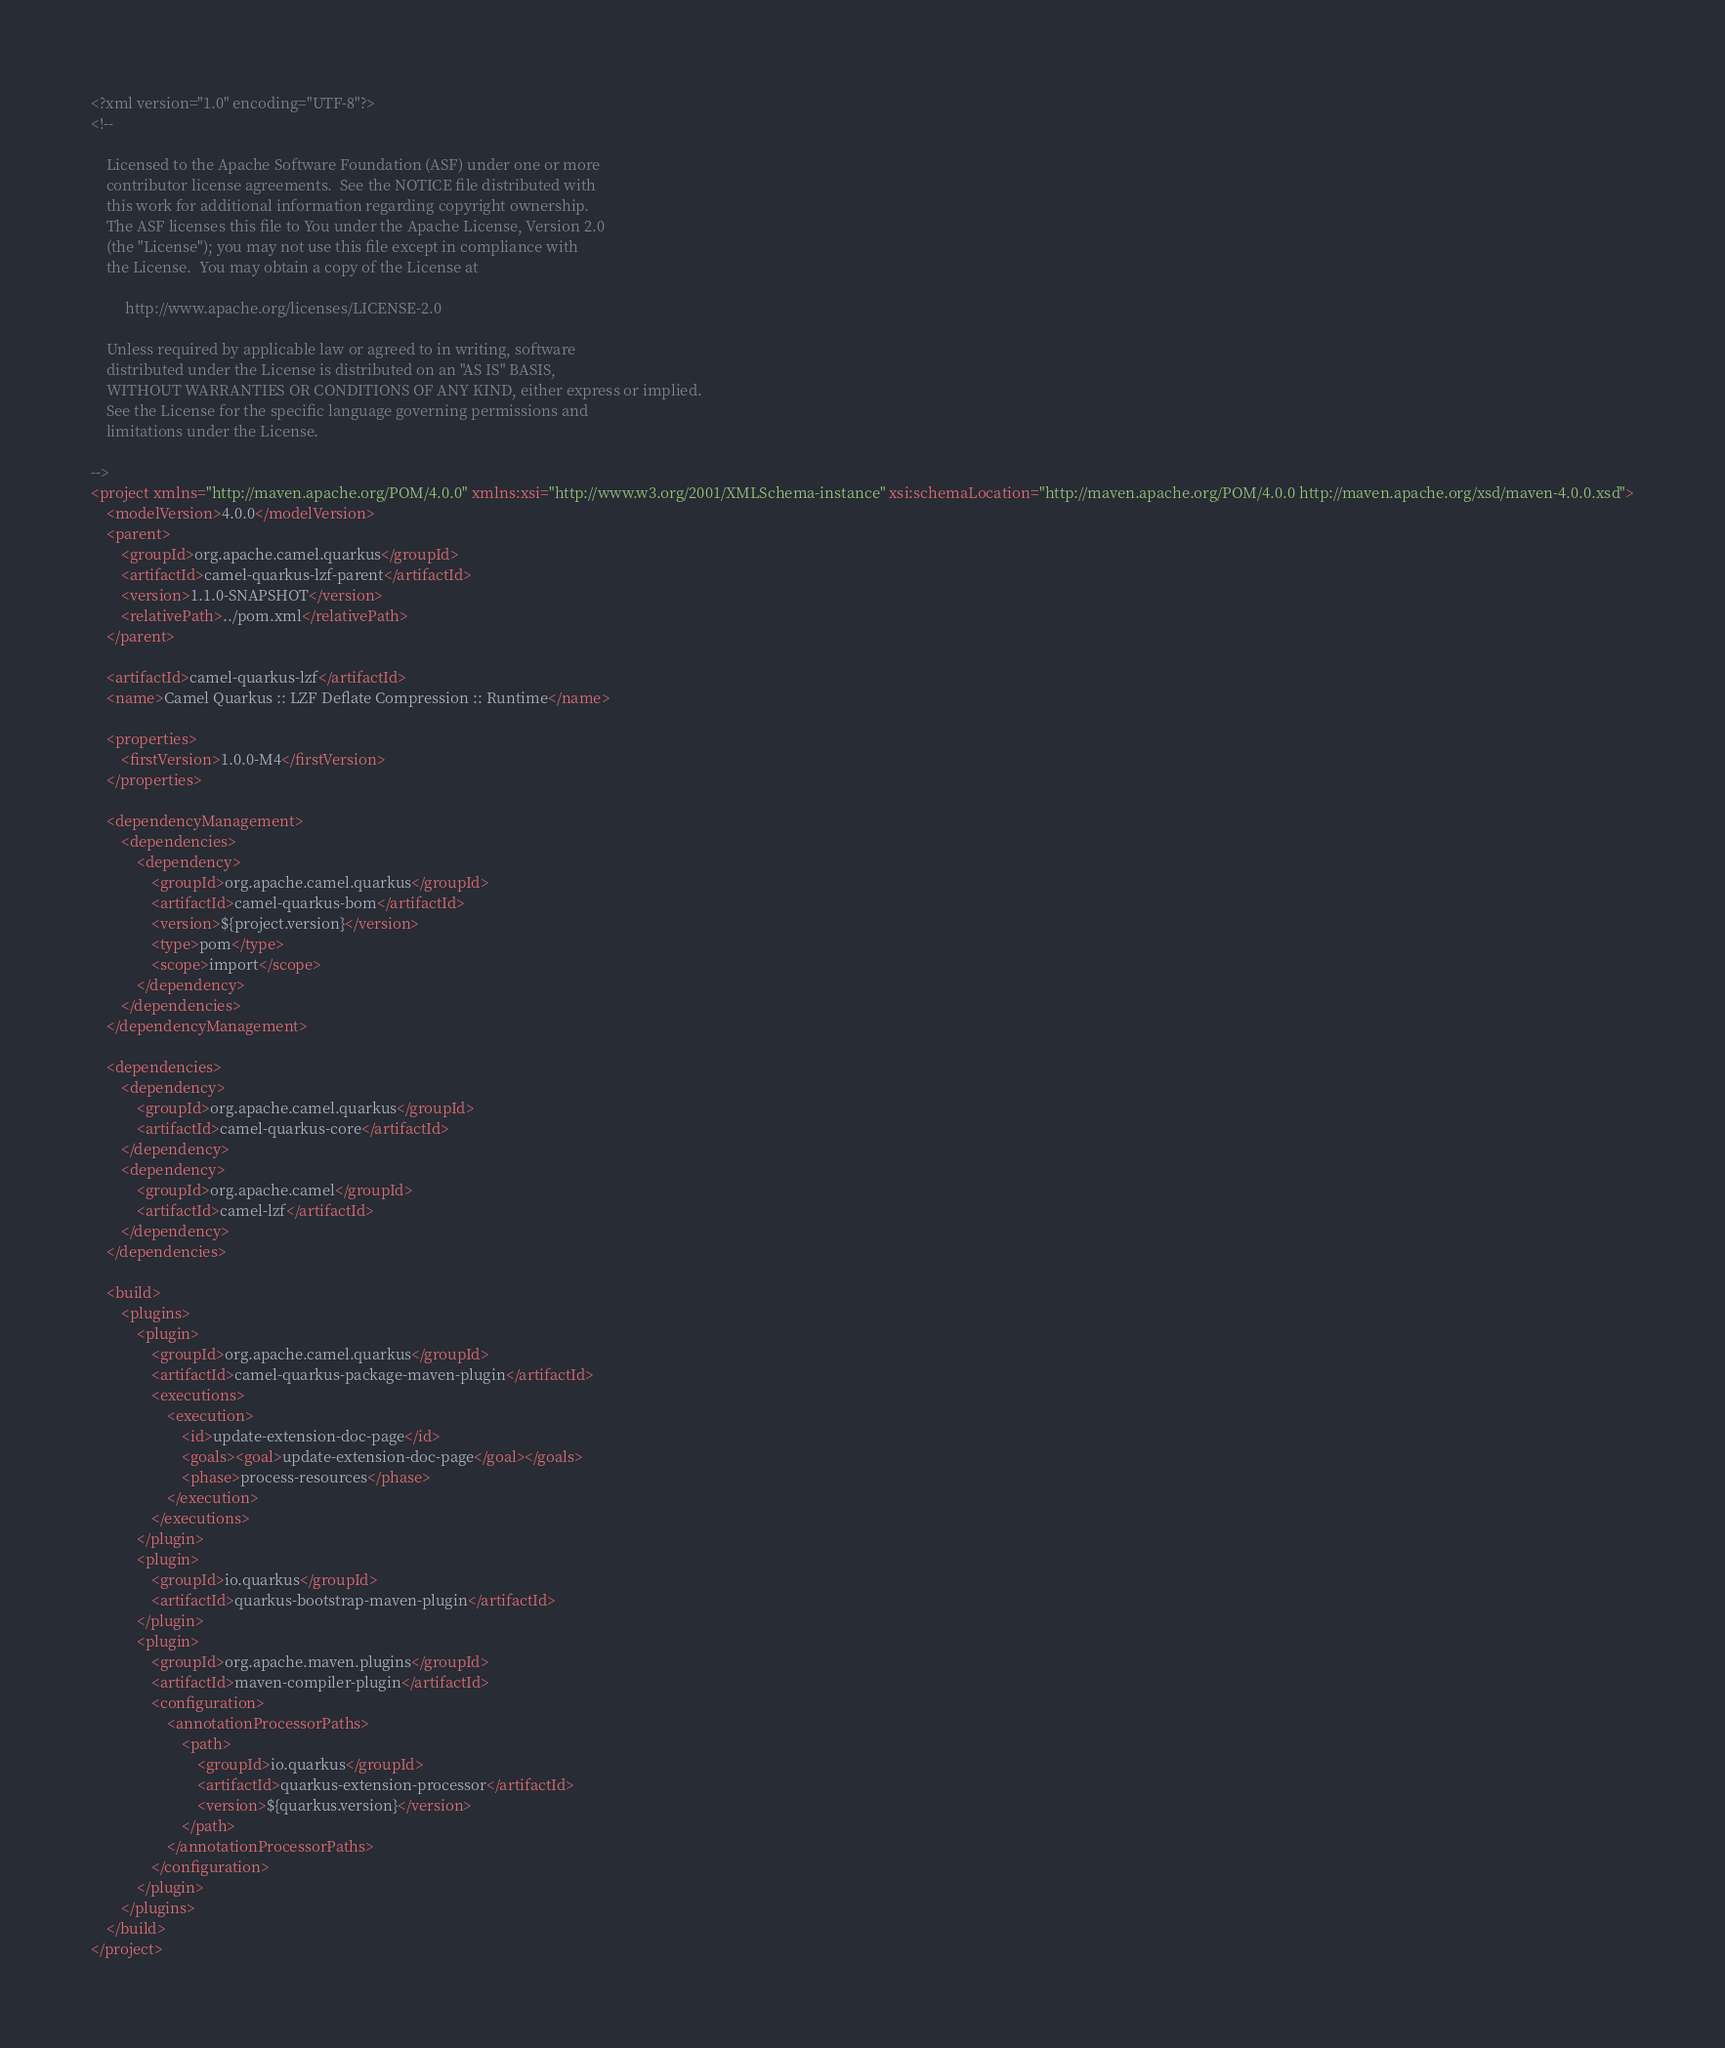<code> <loc_0><loc_0><loc_500><loc_500><_XML_><?xml version="1.0" encoding="UTF-8"?>
<!--

    Licensed to the Apache Software Foundation (ASF) under one or more
    contributor license agreements.  See the NOTICE file distributed with
    this work for additional information regarding copyright ownership.
    The ASF licenses this file to You under the Apache License, Version 2.0
    (the "License"); you may not use this file except in compliance with
    the License.  You may obtain a copy of the License at

         http://www.apache.org/licenses/LICENSE-2.0

    Unless required by applicable law or agreed to in writing, software
    distributed under the License is distributed on an "AS IS" BASIS,
    WITHOUT WARRANTIES OR CONDITIONS OF ANY KIND, either express or implied.
    See the License for the specific language governing permissions and
    limitations under the License.

-->
<project xmlns="http://maven.apache.org/POM/4.0.0" xmlns:xsi="http://www.w3.org/2001/XMLSchema-instance" xsi:schemaLocation="http://maven.apache.org/POM/4.0.0 http://maven.apache.org/xsd/maven-4.0.0.xsd">
    <modelVersion>4.0.0</modelVersion>
    <parent>
        <groupId>org.apache.camel.quarkus</groupId>
        <artifactId>camel-quarkus-lzf-parent</artifactId>
        <version>1.1.0-SNAPSHOT</version>
        <relativePath>../pom.xml</relativePath>
    </parent>

    <artifactId>camel-quarkus-lzf</artifactId>
    <name>Camel Quarkus :: LZF Deflate Compression :: Runtime</name>

    <properties>
        <firstVersion>1.0.0-M4</firstVersion>
    </properties>

    <dependencyManagement>
        <dependencies>
            <dependency>
                <groupId>org.apache.camel.quarkus</groupId>
                <artifactId>camel-quarkus-bom</artifactId>
                <version>${project.version}</version>
                <type>pom</type>
                <scope>import</scope>
            </dependency>
        </dependencies>
    </dependencyManagement>

    <dependencies>
        <dependency>
            <groupId>org.apache.camel.quarkus</groupId>
            <artifactId>camel-quarkus-core</artifactId>
        </dependency>
        <dependency>
            <groupId>org.apache.camel</groupId>
            <artifactId>camel-lzf</artifactId>
        </dependency>
    </dependencies>

    <build>
        <plugins>
            <plugin>
                <groupId>org.apache.camel.quarkus</groupId>
                <artifactId>camel-quarkus-package-maven-plugin</artifactId>
                <executions>
                    <execution>
                        <id>update-extension-doc-page</id>
                        <goals><goal>update-extension-doc-page</goal></goals>
                        <phase>process-resources</phase>
                    </execution>
                </executions>
            </plugin>
            <plugin>
                <groupId>io.quarkus</groupId>
                <artifactId>quarkus-bootstrap-maven-plugin</artifactId>
            </plugin>
            <plugin>
                <groupId>org.apache.maven.plugins</groupId>
                <artifactId>maven-compiler-plugin</artifactId>
                <configuration>
                    <annotationProcessorPaths>
                        <path>
                            <groupId>io.quarkus</groupId>
                            <artifactId>quarkus-extension-processor</artifactId>
                            <version>${quarkus.version}</version>
                        </path>
                    </annotationProcessorPaths>
                </configuration>
            </plugin>
        </plugins>
    </build>
</project>
</code> 